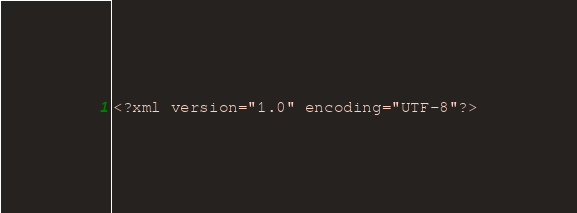<code> <loc_0><loc_0><loc_500><loc_500><_XML_><?xml version="1.0" encoding="UTF-8"?></code> 